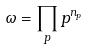Convert formula to latex. <formula><loc_0><loc_0><loc_500><loc_500>\omega = \prod _ { p } p ^ { n _ { p } }</formula> 